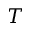<formula> <loc_0><loc_0><loc_500><loc_500>T</formula> 